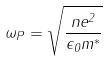<formula> <loc_0><loc_0><loc_500><loc_500>\omega _ { P } = \sqrt { \frac { n e ^ { 2 } } { \epsilon _ { 0 } m ^ { * } } }</formula> 